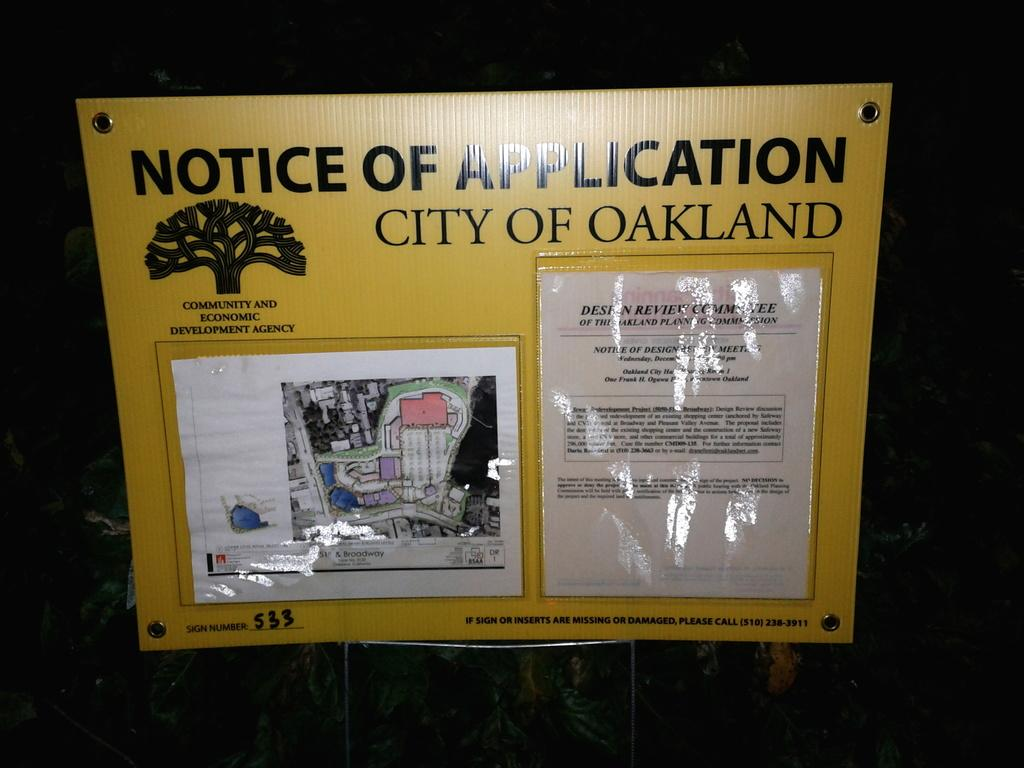<image>
Describe the image concisely. A notice of application from the City of Oakland. 